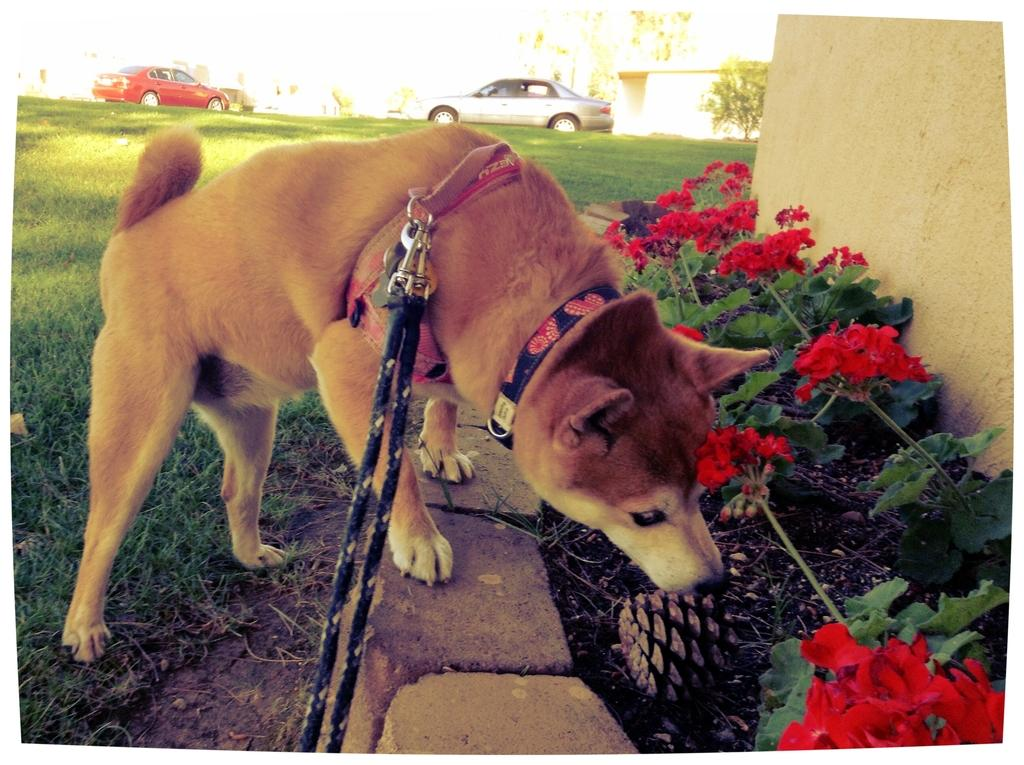What type of animal is present in the image? There is a dog in the image. What is the dog wearing? The dog is wearing a belt. What type of vegetation can be seen in the image? There is grass, flowers, and plants visible in the image. What is the background of the image? There is a wall, cars, and a tree visible in the background. How many babies are visible in the image? There are no babies present in the image. What type of wound can be seen on the dog's paw in the image? There is no wound visible on the dog's paw in the image, as the dog is not injured. 